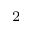<formula> <loc_0><loc_0><loc_500><loc_500>_ { 2 }</formula> 